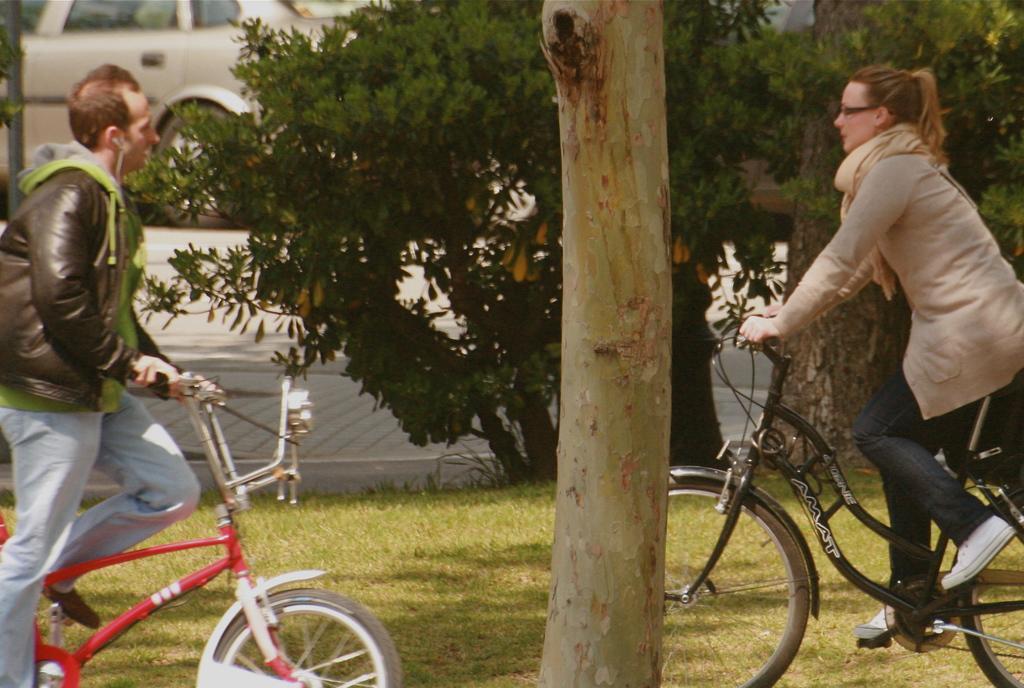Could you give a brief overview of what you see in this image? The image is clicked on the roads. There are two persons in the image a man and a woman. To the right the woman is riding black color bicycle. To the left the man is riding red color bicycle. In the background there is a car. In the middle there is a tree and plant behind it. At the bottom there is a green color grass. 